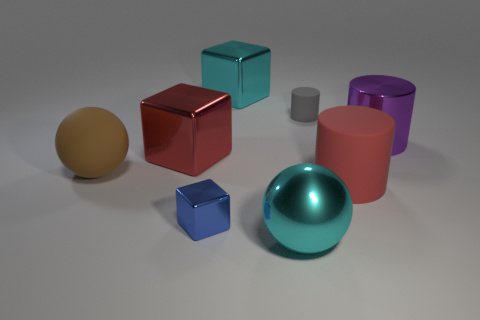Subtract all small gray cylinders. How many cylinders are left? 2 Add 2 tiny blue metal blocks. How many objects exist? 10 Subtract all blue blocks. How many blocks are left? 2 Subtract 1 cubes. How many cubes are left? 2 Subtract all spheres. How many objects are left? 6 Subtract all large brown matte cubes. Subtract all blue blocks. How many objects are left? 7 Add 3 small metal objects. How many small metal objects are left? 4 Add 8 small green blocks. How many small green blocks exist? 8 Subtract 1 cyan balls. How many objects are left? 7 Subtract all purple cylinders. Subtract all gray spheres. How many cylinders are left? 2 